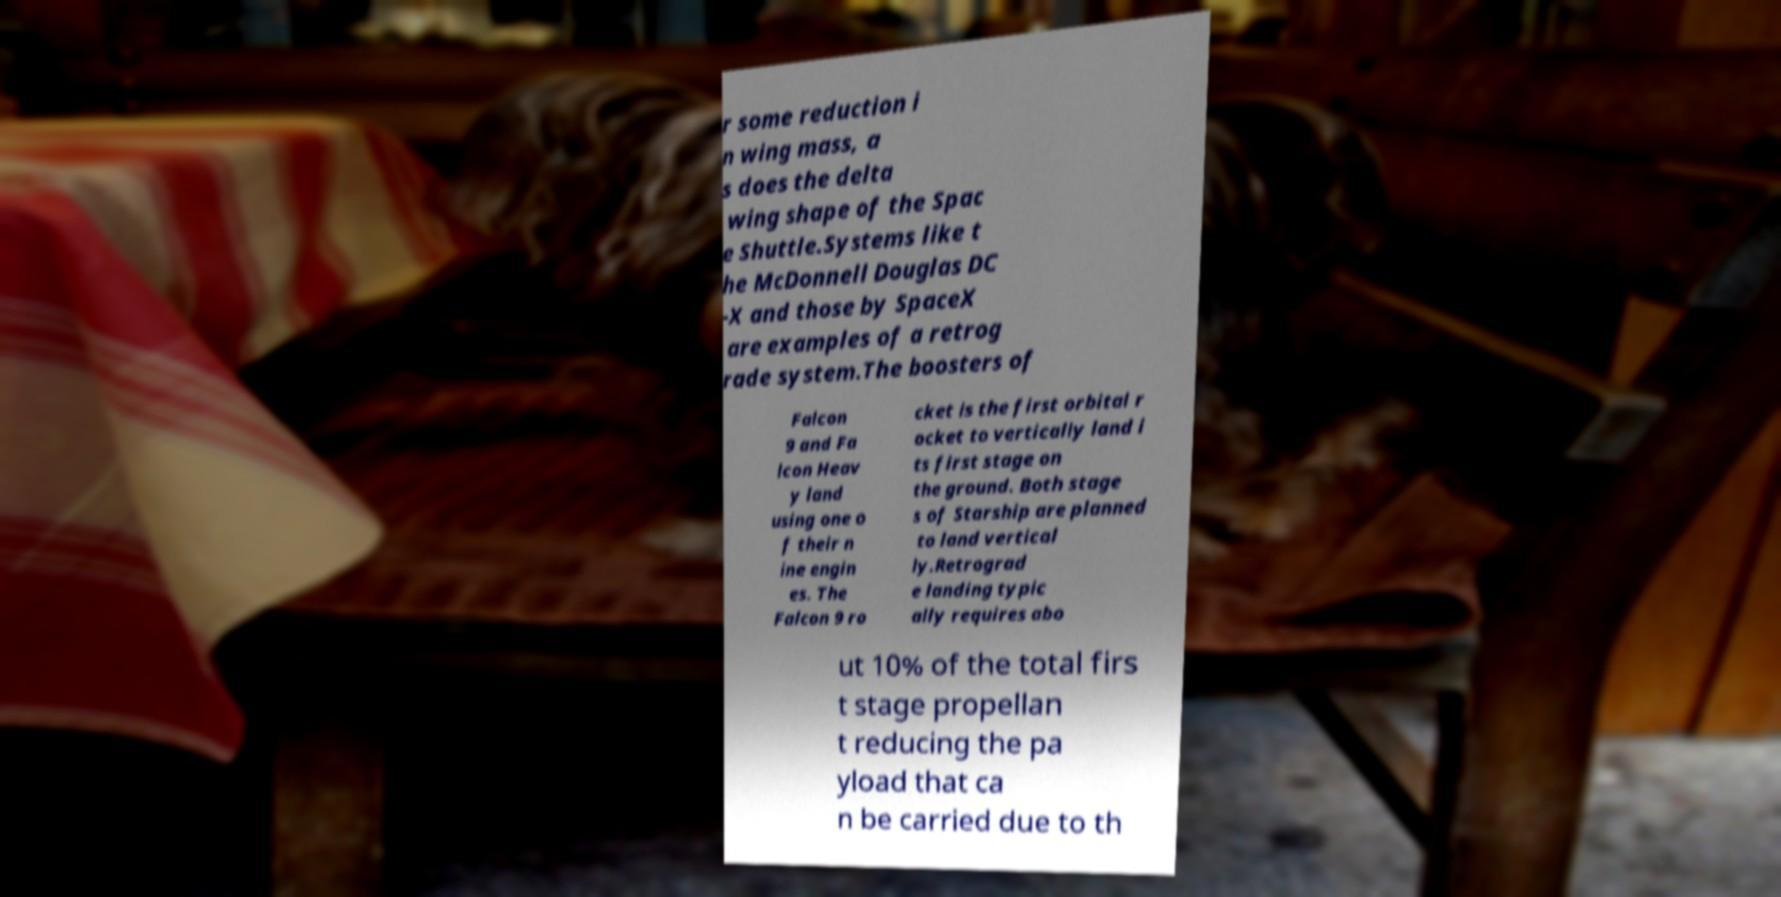There's text embedded in this image that I need extracted. Can you transcribe it verbatim? r some reduction i n wing mass, a s does the delta wing shape of the Spac e Shuttle.Systems like t he McDonnell Douglas DC -X and those by SpaceX are examples of a retrog rade system.The boosters of Falcon 9 and Fa lcon Heav y land using one o f their n ine engin es. The Falcon 9 ro cket is the first orbital r ocket to vertically land i ts first stage on the ground. Both stage s of Starship are planned to land vertical ly.Retrograd e landing typic ally requires abo ut 10% of the total firs t stage propellan t reducing the pa yload that ca n be carried due to th 